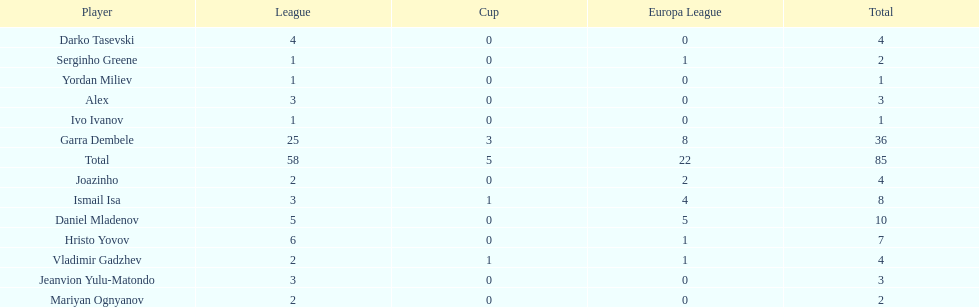Which total is higher, the europa league total or the league total? League. 